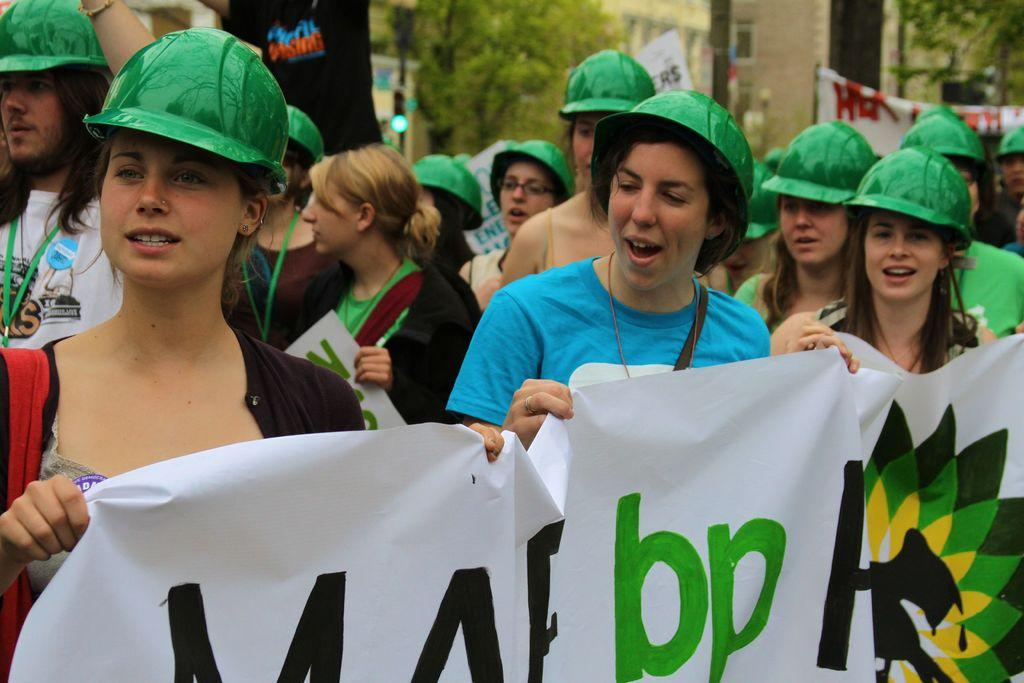What can be seen in the image? There is a group of women in the image. What are the women wearing on their heads? The women are wearing green color caps. What are some of the women holding? Some women are holding a hoarding board. What is visible at the top of the image? There is a wall visible at the top of the image. What type of vegetation can be seen in the image? There are trees in the image. What type of oven can be seen in the image? There is no oven present in the image. What discovery was made by the women in the image? There is no indication of a discovery in the image; it simply shows a group of women wearing green caps and holding a hoarding board. 